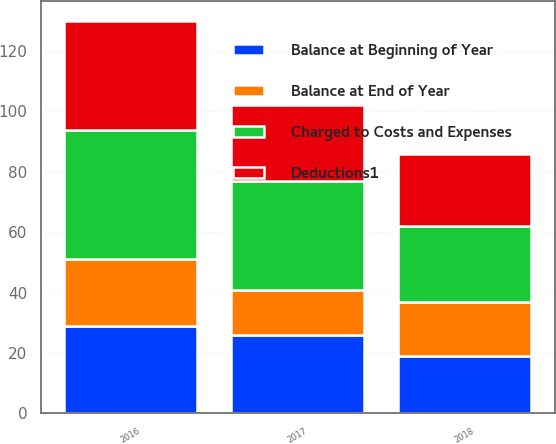Convert chart to OTSL. <chart><loc_0><loc_0><loc_500><loc_500><stacked_bar_chart><ecel><fcel>2018<fcel>2017<fcel>2016<nl><fcel>Charged to Costs and Expenses<fcel>25<fcel>36<fcel>43<nl><fcel>Balance at End of Year<fcel>18<fcel>15<fcel>22<nl><fcel>Balance at Beginning of Year<fcel>19<fcel>26<fcel>29<nl><fcel>Deductions1<fcel>24<fcel>25<fcel>36<nl></chart> 